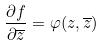Convert formula to latex. <formula><loc_0><loc_0><loc_500><loc_500>\frac { \partial f } { \partial \overline { z } } = \varphi ( z , \overline { z } )</formula> 